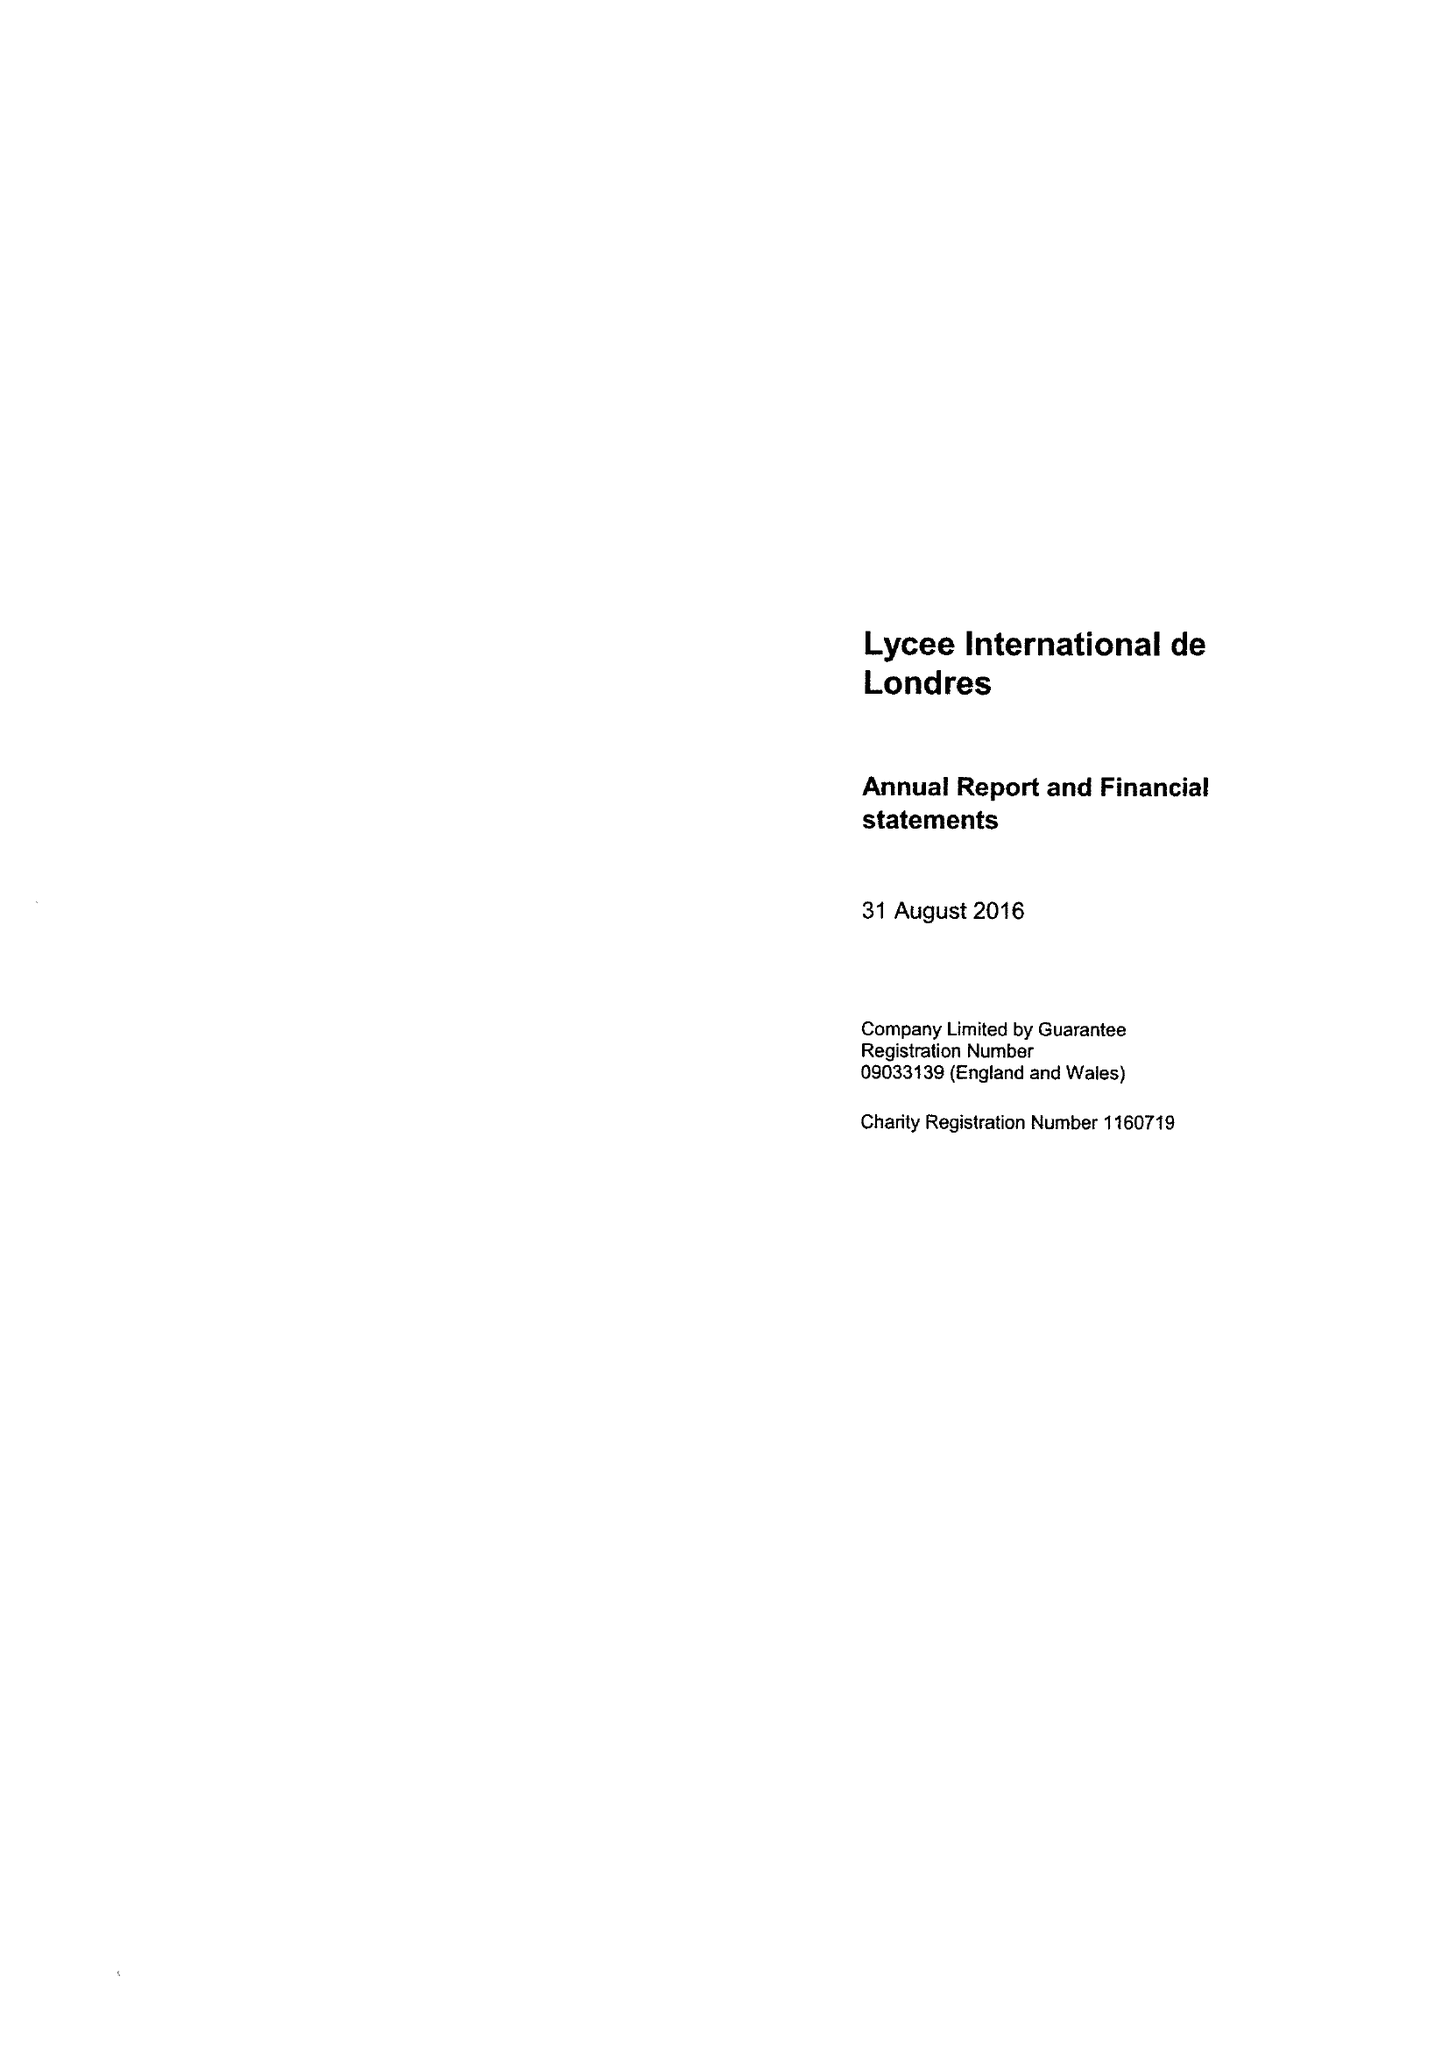What is the value for the charity_name?
Answer the question using a single word or phrase. Lycee International De Londres 